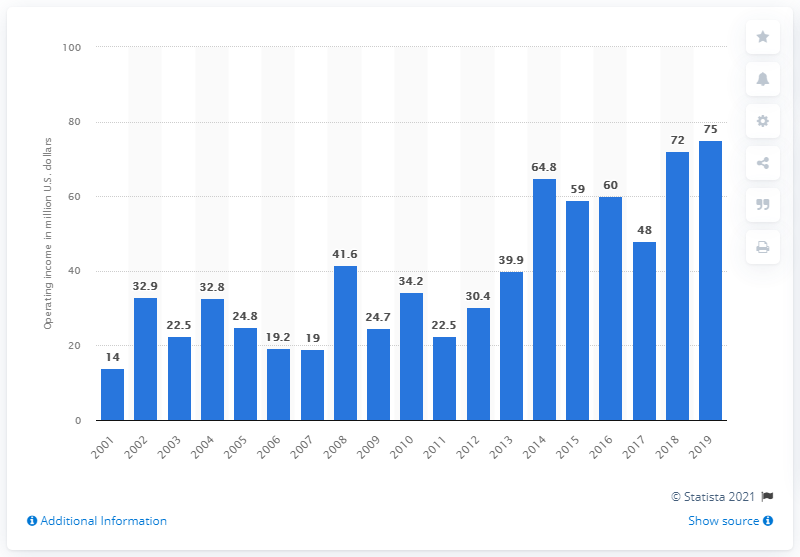Outline some significant characteristics in this image. The operating income of the Los Angeles Chargers for the 2019 season was $75 million. 